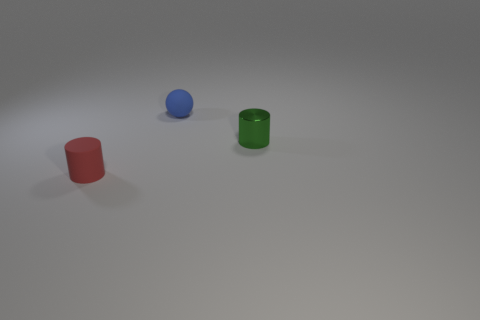What number of green objects are either tiny matte balls or small matte cylinders? 0 